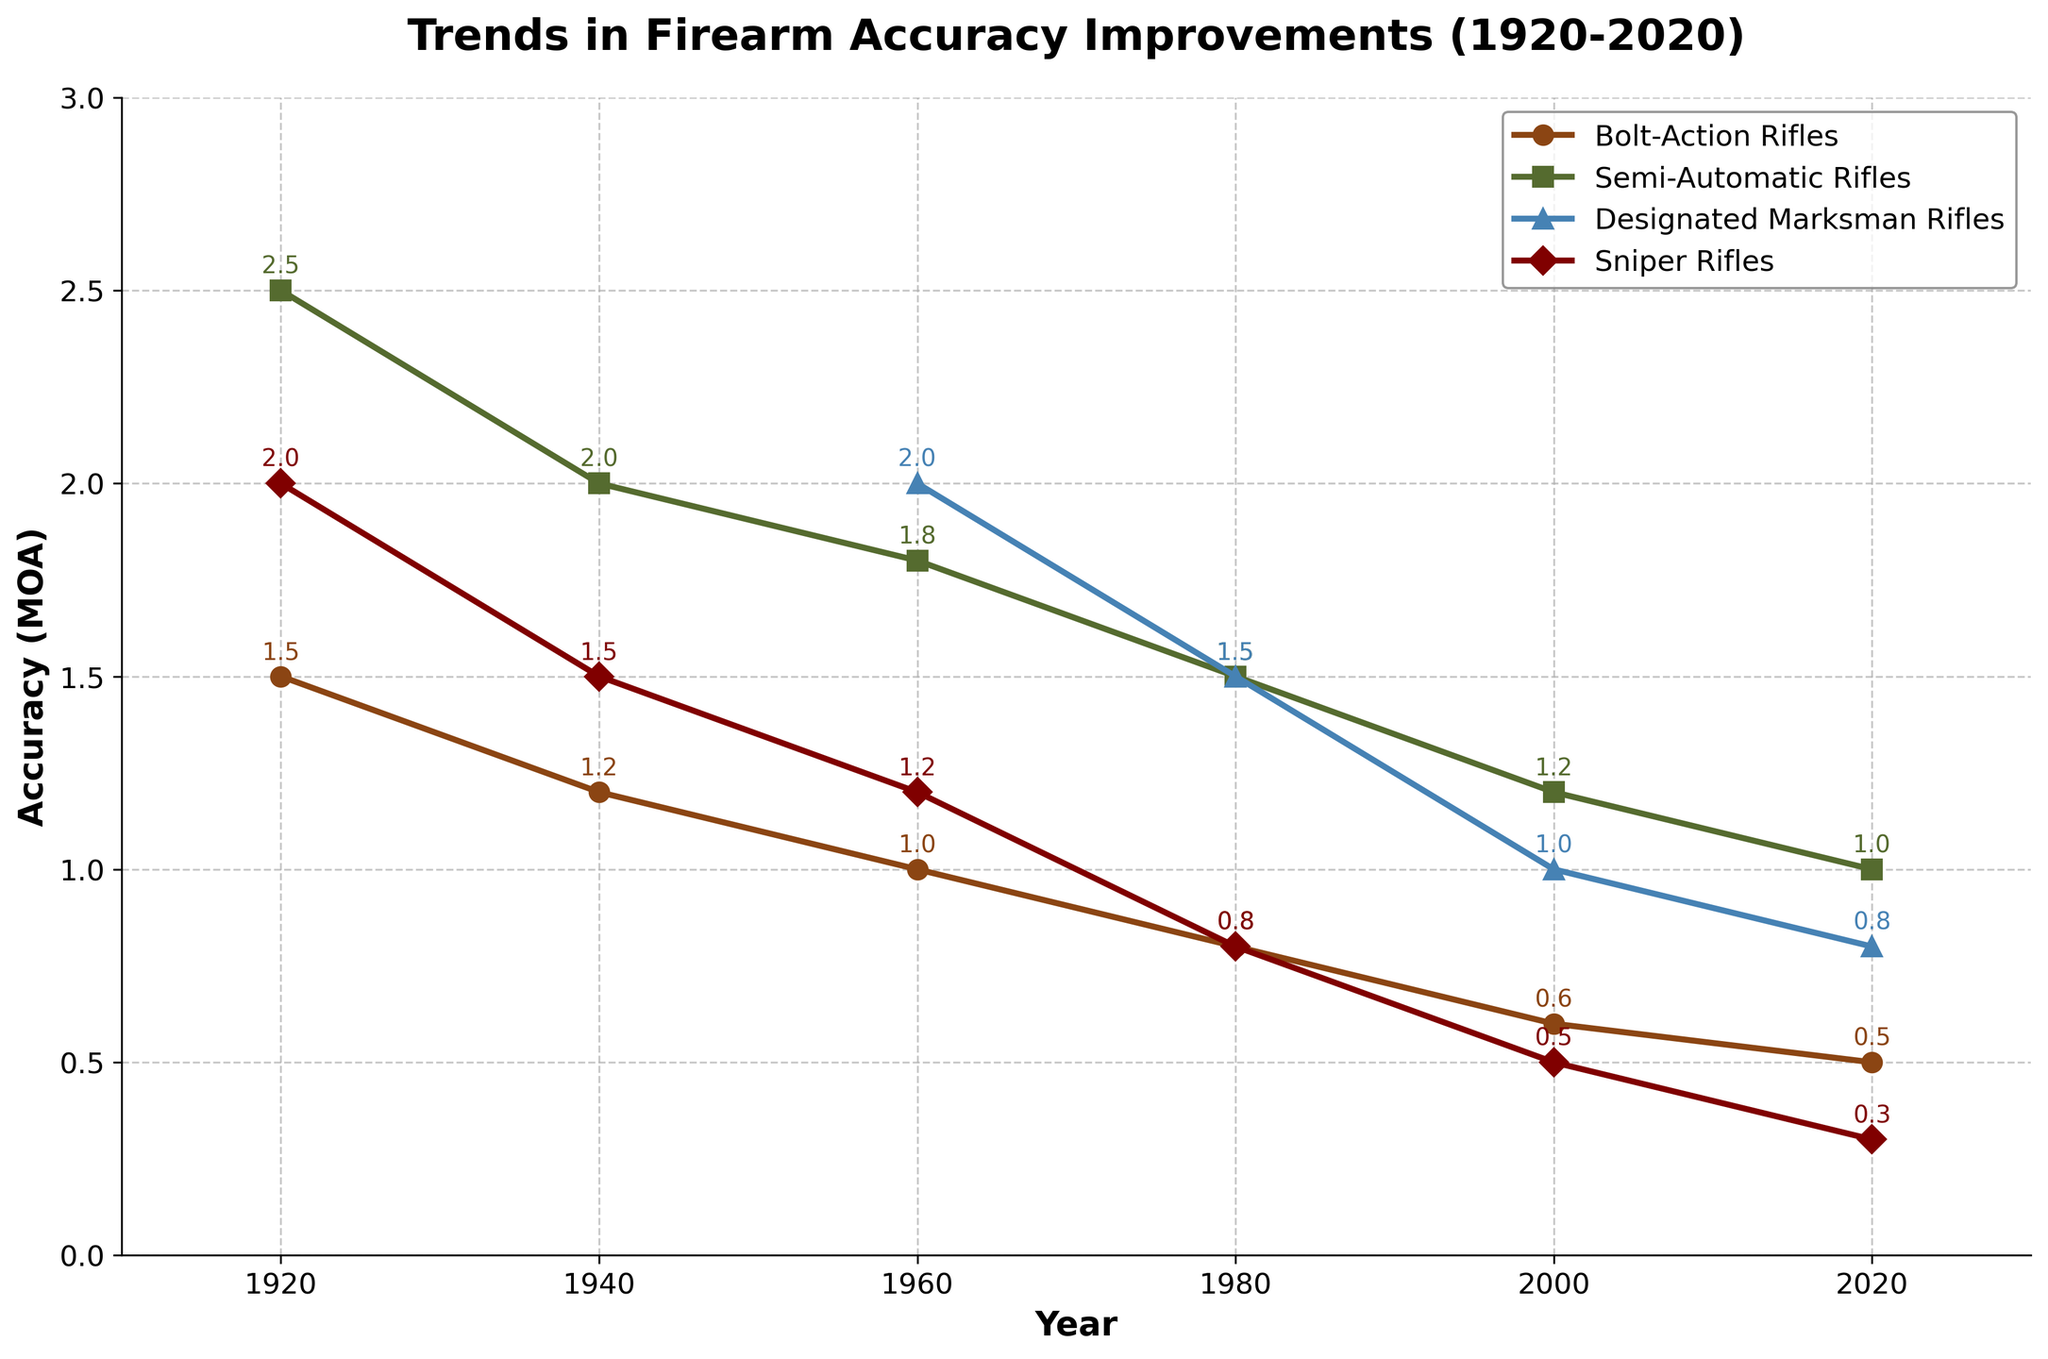Which rifle type shows the most significant improvement in accuracy from 1920 to 2020? To determine the most significant improvement, calculate the difference in accuracy values from 1920 to 2020 for each rifle type. Bolt-Action Rifles improved from 1.5 to 0.5 (a reduction of 1.0), Semi-Automatic Rifles from 2.5 to 1.0 (a reduction of 1.5), Designated Marksman Rifles from 2.0 to 0.8 (a reduction of 1.2), and Sniper Rifles from 2.0 to 0.3 (a reduction of 1.7). The Sniper Rifles show the most significant improvement.
Answer: Sniper Rifles Between Semi-Automatic Rifles and Bolt-Action Rifles, which had better accuracy in 1960? In 1960, the accuracy of Bolt-Action Rifles was 1.0, while the accuracy of Semi-Automatic Rifles was 1.8. Since lower values indicate better accuracy, Bolt-Action Rifles had better accuracy in 1960.
Answer: Bolt-Action Rifles What is the overall trend in accuracy for Designated Marksman Rifles from 1960 to 2020? Observing the data from 1960 to 2020 for Designated Marksman Rifles, the accuracy improves from 2.0 in 1960 to 1.0 in 2000 and further improves to 0.8 in 2020. The trend is a continuous improvement in accuracy.
Answer: Continuous improvement Which rifle type had an accuracy of 1.5 MOA in 1980? Looking at the 1980 data point, both Semi-Automatic Rifles and Designated Marksman Rifles had an accuracy of 1.5 MOA.
Answer: Semi-Automatic Rifles and Designated Marksman Rifles What is the average accuracy improvement for Bolt-Action Rifles and Sniper Rifles from 1920 to 2020? For Bolt-Action Rifles, the accuracy improved from 1.5 to 0.5 (an improvement of 1.0). For Sniper Rifles, the accuracy improved from 2.0 to 0.3 (an improvement of 1.7). The average improvement is calculated as (1.0 + 1.7) / 2 = 1.35.
Answer: 1.35 Compare the accuracy of Bolt-Action Rifles and Sniper Rifles in the year 2000. Which one is better? In 2000, the accuracy of Bolt-Action Rifles was 0.6, and the accuracy of Sniper Rifles was 0.5. Since lower values indicate better accuracy, Sniper Rifles had better accuracy in 2000.
Answer: Sniper Rifles Which rifle type was not present in the dataset before 1960? The accuracy values for Designated Marksman Rifles are shown as "N/A" (not available) before 1960, indicating that this rifle type was not present in the dataset before 1960.
Answer: Designated Marksman Rifles 